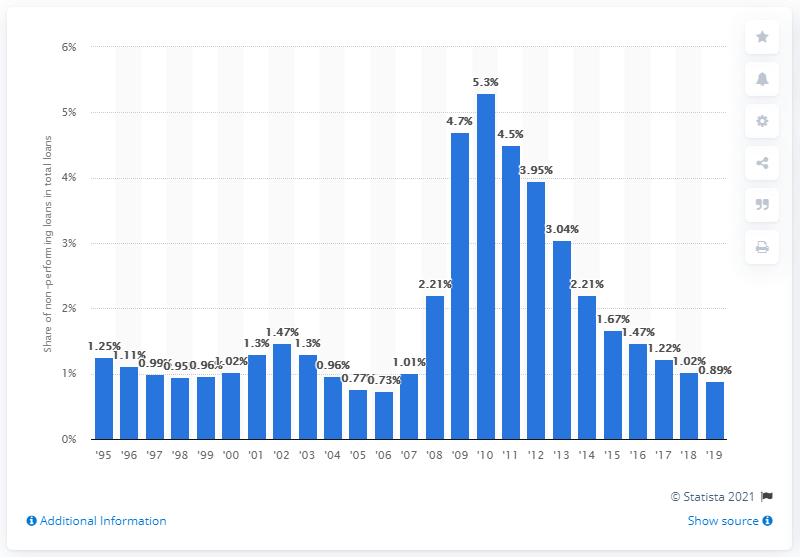Identify some key points in this picture. In 2019, approximately 8.9% of loans were considered non-performing. 